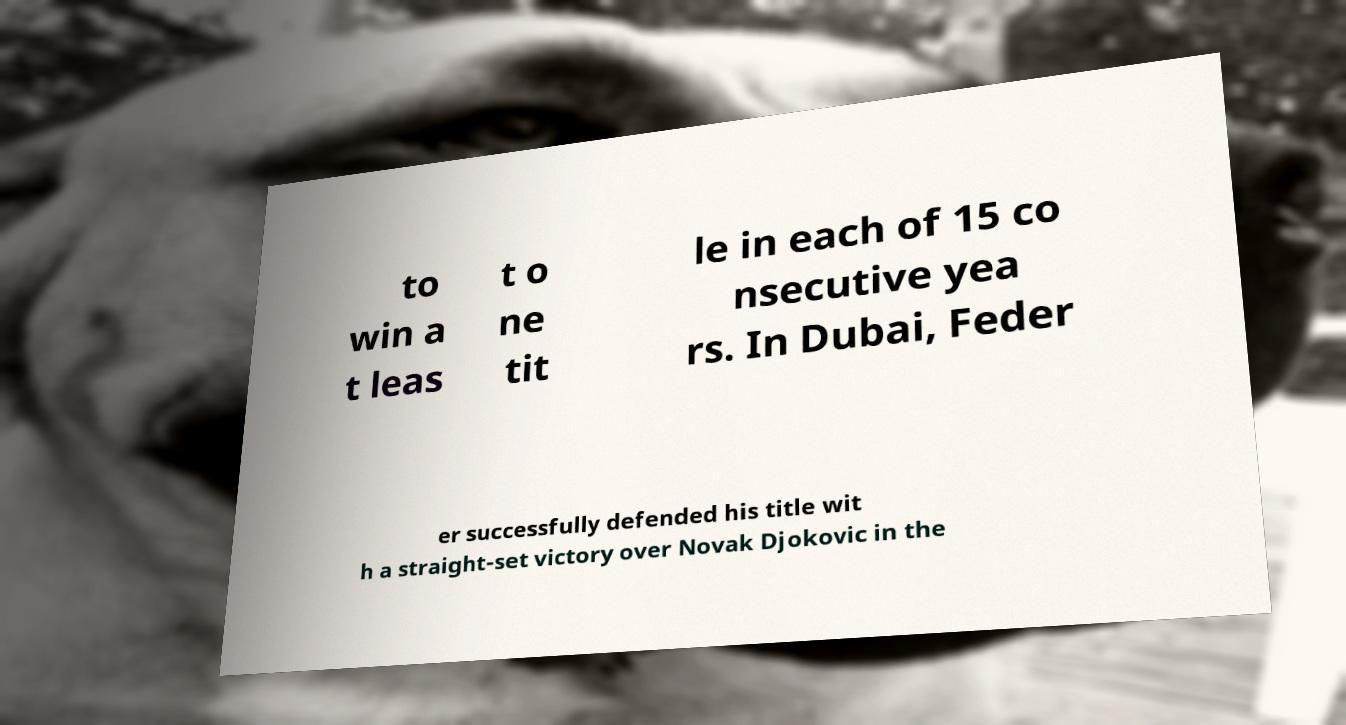Could you assist in decoding the text presented in this image and type it out clearly? to win a t leas t o ne tit le in each of 15 co nsecutive yea rs. In Dubai, Feder er successfully defended his title wit h a straight-set victory over Novak Djokovic in the 